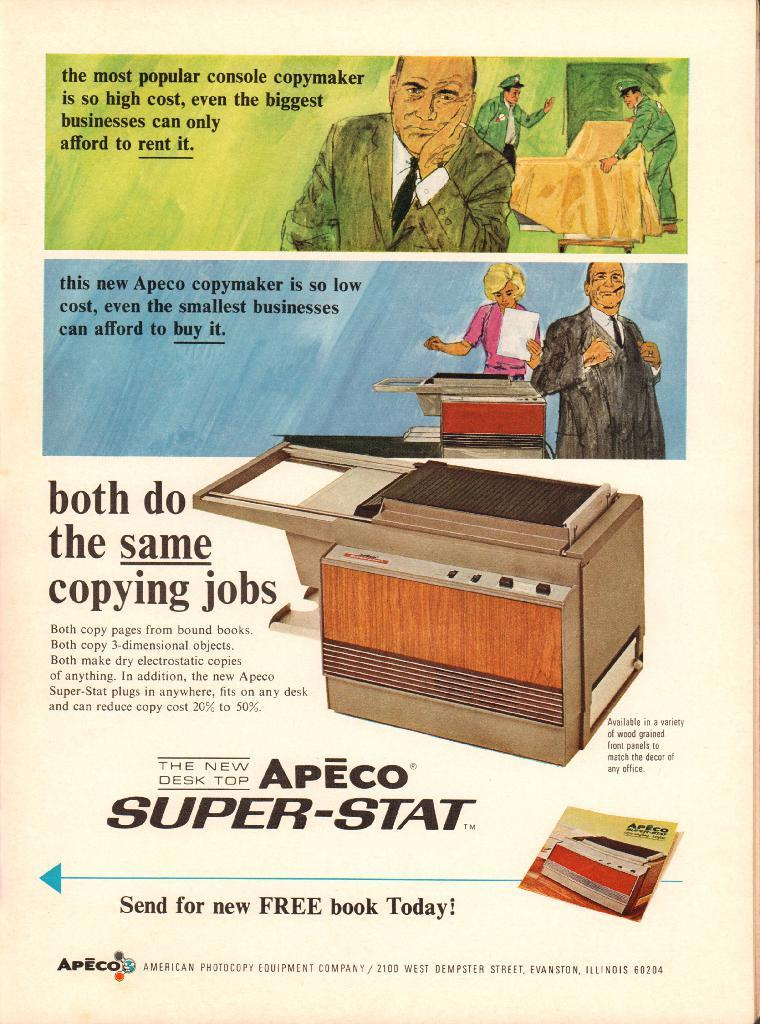<image>
Provide a brief description of the given image. Ad old fashioned ad promotes the sale of Apeco copymakers. 